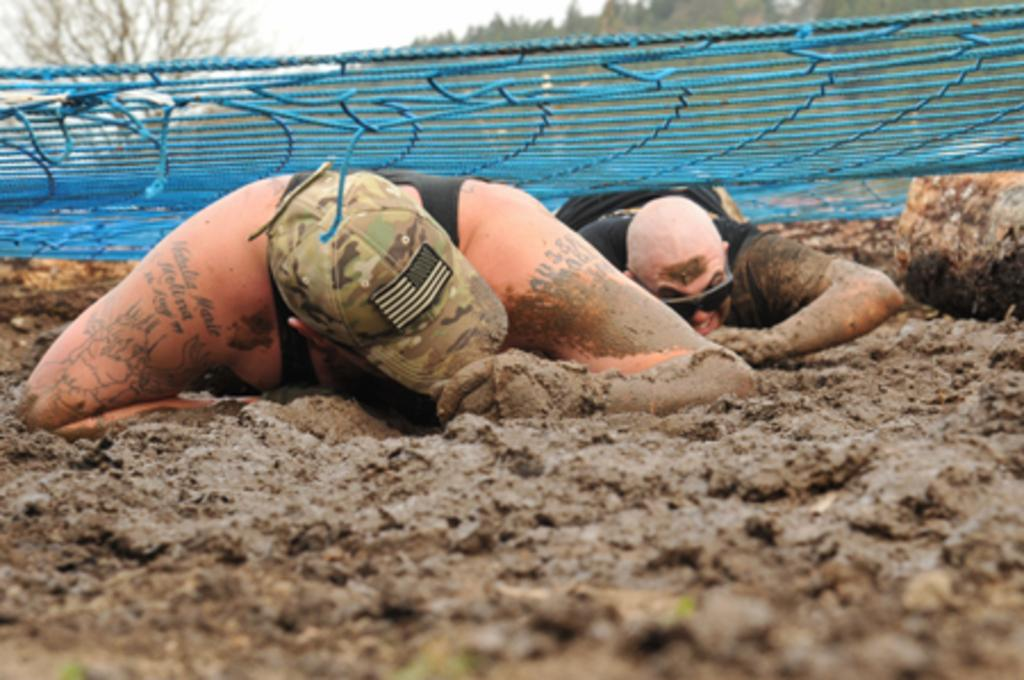What are the men in the image doing? The men in the image are laying on the ground. What is covering the men in the image? There is a net on top of the men. What is the ground made of in the image? The ground is made of mud. What type of vegetation can be seen in the image? There are trees visible in the image. How would you describe the weather in the image? The sky appears to be cloudy in the image. What type of key is being used to unlock the plants in the image? There are no keys or plants being unlocked in the image; it features men laying on the ground with a net on top of them. What type of wood is being used to build the trees in the image? There is no wood being used to build the trees in the image; they are natural vegetation. 